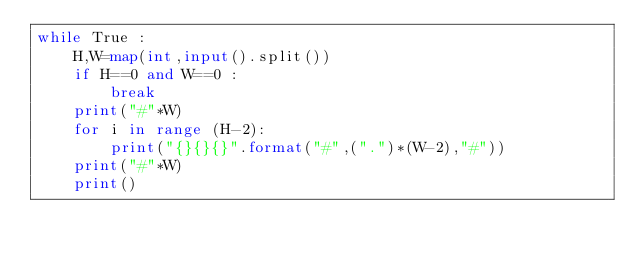Convert code to text. <code><loc_0><loc_0><loc_500><loc_500><_Python_>while True :
    H,W=map(int,input().split())
    if H==0 and W==0 :
        break
    print("#"*W)
    for i in range (H-2):
        print("{}{}{}".format("#",(".")*(W-2),"#"))
    print("#"*W) 
    print()

</code> 